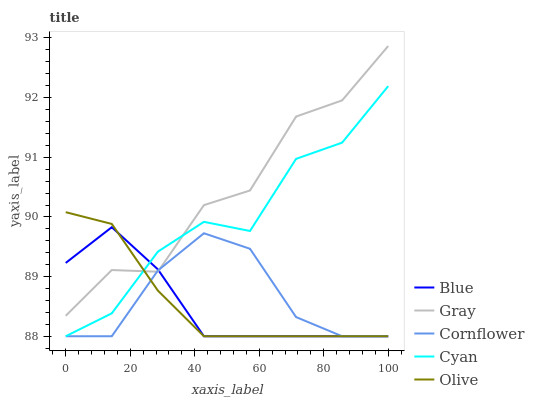Does Cyan have the minimum area under the curve?
Answer yes or no. No. Does Cyan have the maximum area under the curve?
Answer yes or no. No. Is Cyan the smoothest?
Answer yes or no. No. Is Cyan the roughest?
Answer yes or no. No. Does Gray have the lowest value?
Answer yes or no. No. Does Cyan have the highest value?
Answer yes or no. No. 